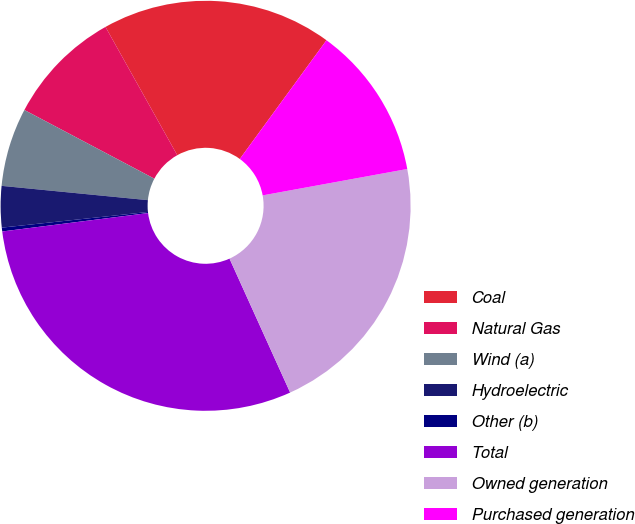Convert chart. <chart><loc_0><loc_0><loc_500><loc_500><pie_chart><fcel>Coal<fcel>Natural Gas<fcel>Wind (a)<fcel>Hydroelectric<fcel>Other (b)<fcel>Total<fcel>Owned generation<fcel>Purchased generation<nl><fcel>18.16%<fcel>9.14%<fcel>6.19%<fcel>3.25%<fcel>0.3%<fcel>29.77%<fcel>21.11%<fcel>12.09%<nl></chart> 